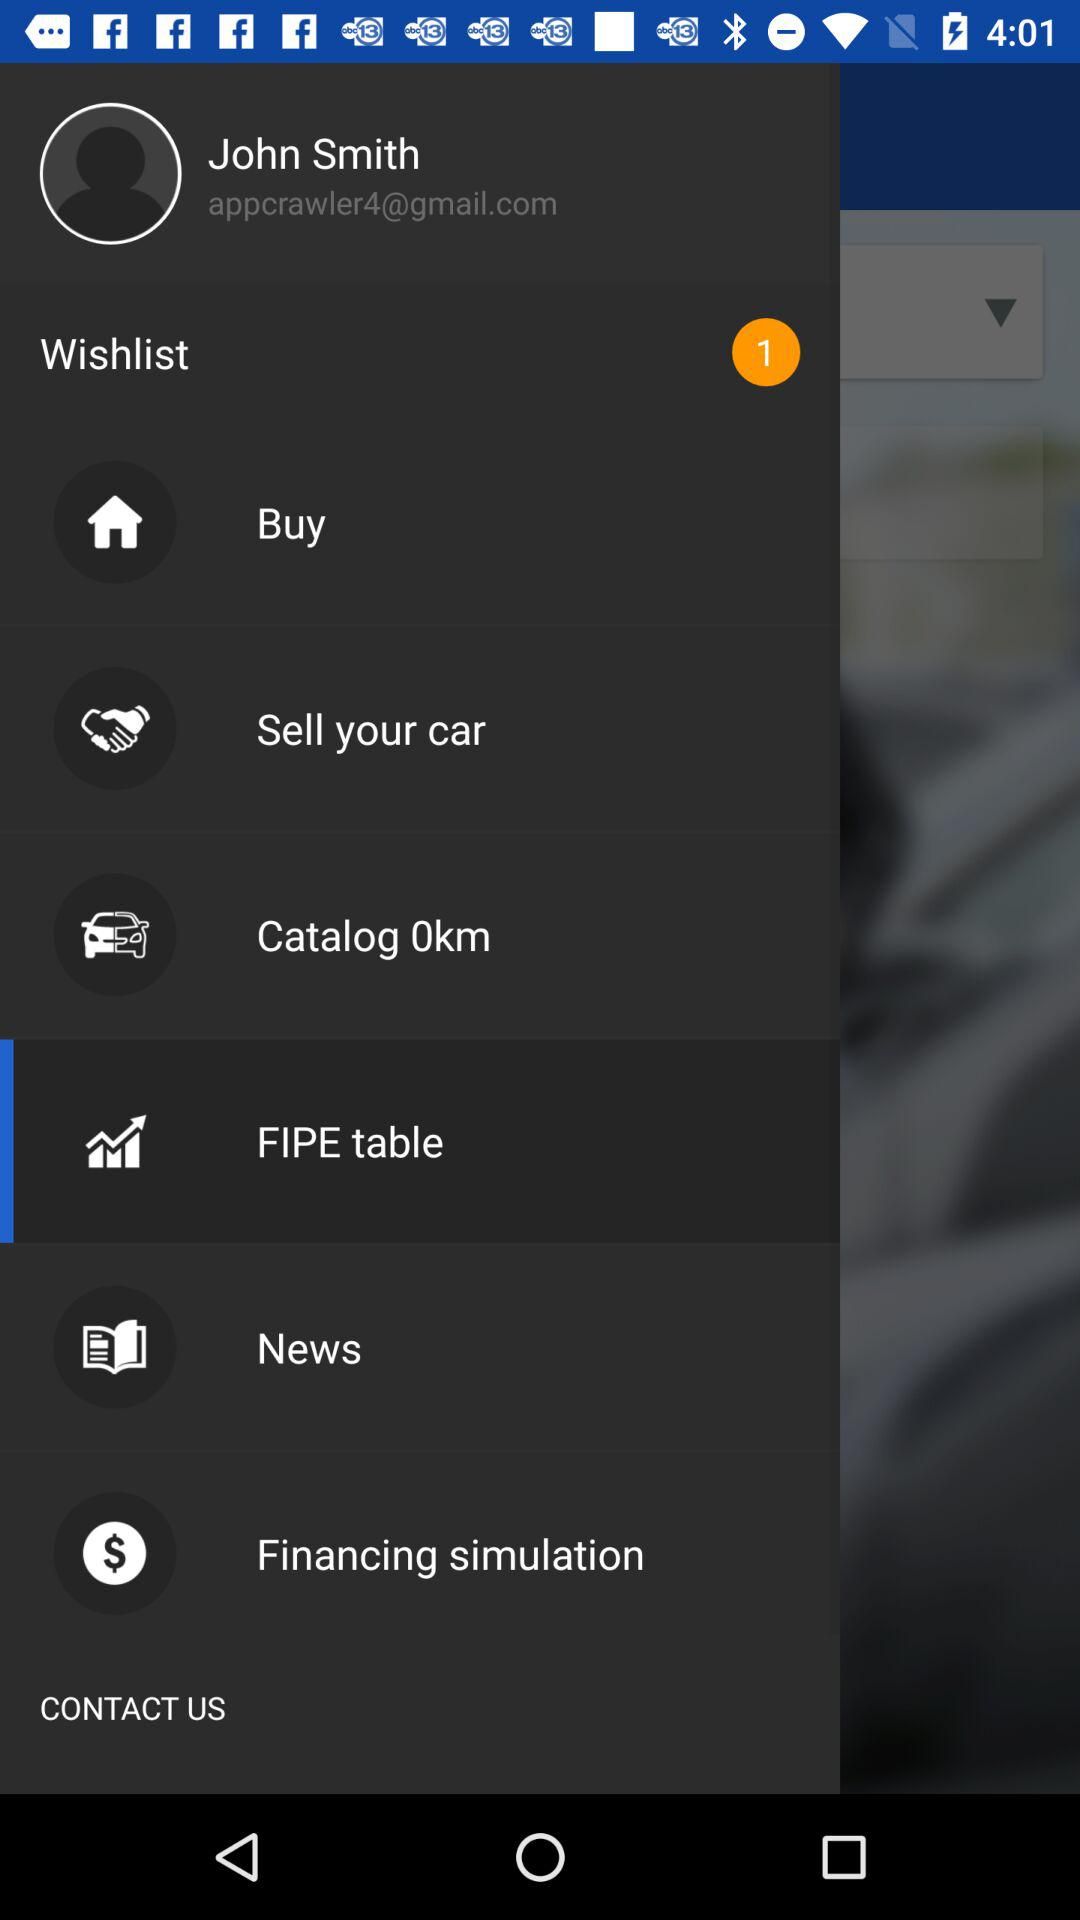What is the name? The name is John Smith. 